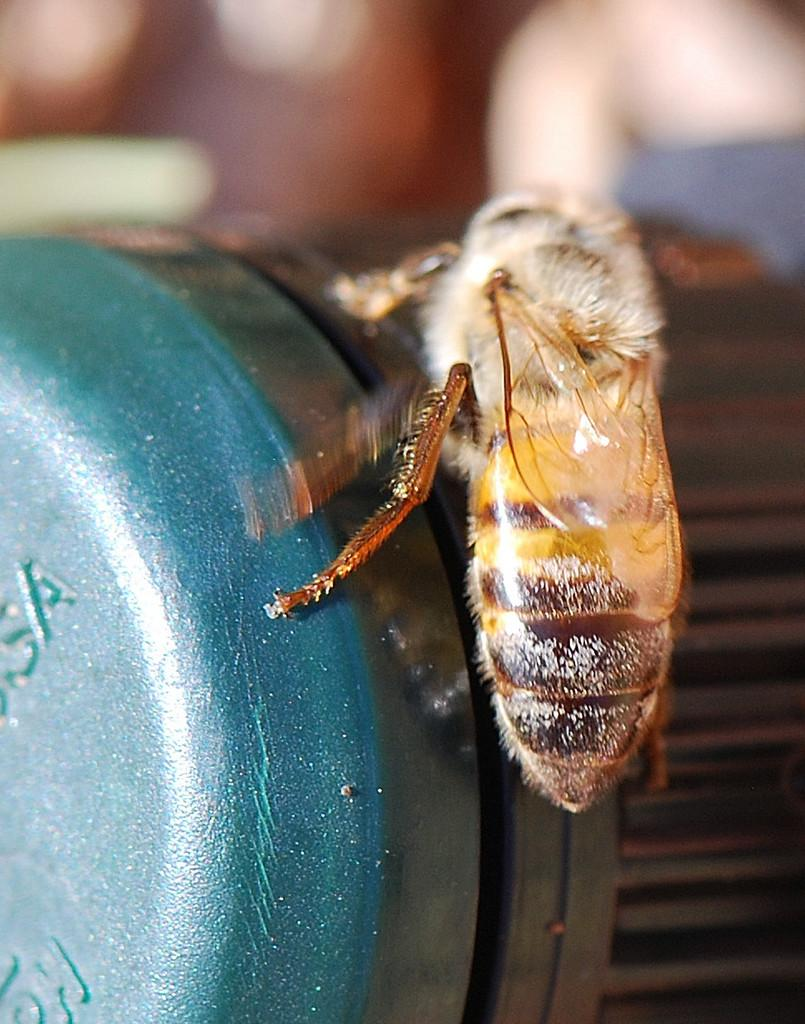What type of creature can be seen in the image? There is an insect in the image. Where is the insect located in the image? The insect is on an object. Can you describe the background of the image? The background of the image is blurred. What type of memory is stored in the image? There is no memory present in the image; it features an insect on an object with a blurred background. What type of flag can be seen in the image? There is no flag present in the image. 